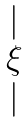<formula> <loc_0><loc_0><loc_500><loc_500>\begin{matrix} | \\ \xi \\ | \end{matrix}</formula> 